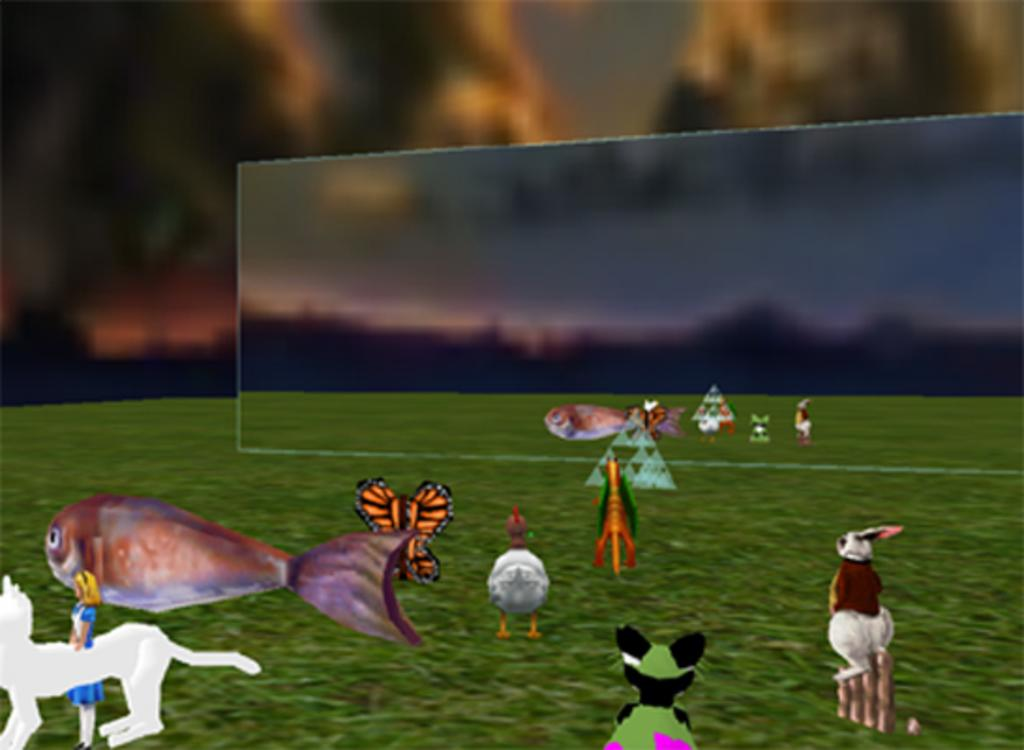What types of living organisms can be seen in the picture? Various animals are present in the picture. What type of vegetation is visible in the picture? There is grass in the picture. What else can be seen in the picture besides animals and grass? There are other objects in the picture. How would you describe the background of the picture? The background of the picture is blurred. What type of alarm can be heard going off in the picture? There is no alarm present in the picture, as it is a still image and cannot produce sound. 